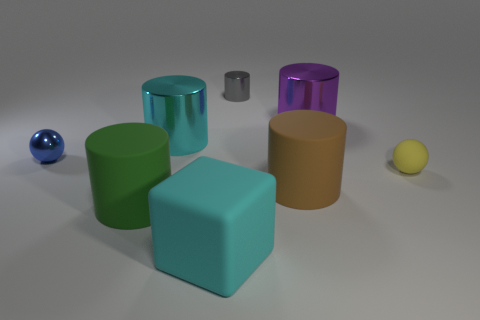Subtract all cyan cylinders. How many cylinders are left? 4 Subtract all large purple metallic cylinders. How many cylinders are left? 4 Subtract all red cylinders. Subtract all cyan cubes. How many cylinders are left? 5 Add 2 large cyan shiny things. How many objects exist? 10 Subtract all cylinders. How many objects are left? 3 Add 2 cyan cylinders. How many cyan cylinders exist? 3 Subtract 0 yellow cubes. How many objects are left? 8 Subtract all large green cylinders. Subtract all gray cylinders. How many objects are left? 6 Add 2 large purple metal cylinders. How many large purple metal cylinders are left? 3 